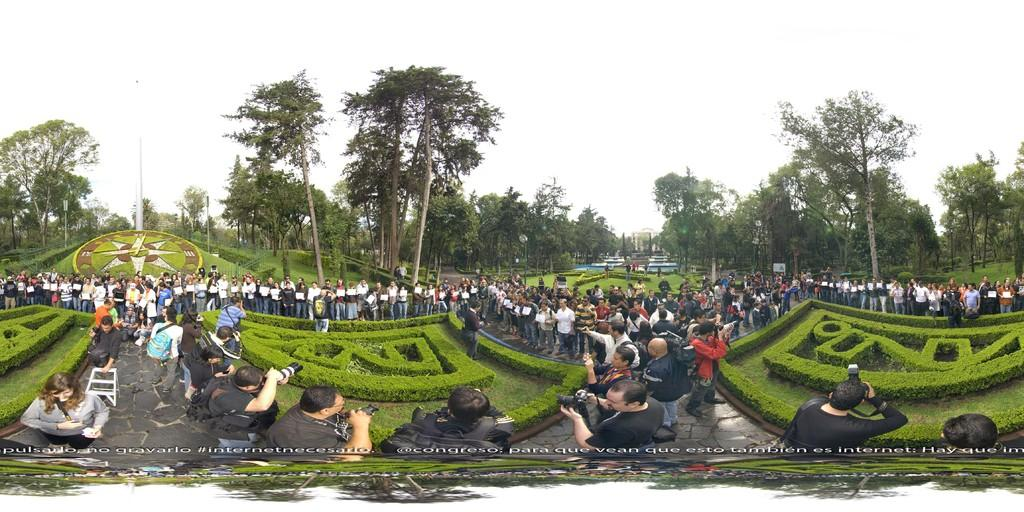What are the people at the bottom of the image doing? The people are standing at the bottom of the image, and they are holding cameras and bags. What can be seen behind the people in the image? There is grass and trees visible behind the people in the image. What is visible at the top of the image? The sky is visible at the top of the image. Reasoning: Let' Let's think step by step in order to produce the conversation. We start by identifying the main subjects in the image, which are the people standing at the bottom. Then, we describe what they are doing, which is holding cameras and bags. Next, we expand the conversation to include the background elements, such as the grass, trees, and sky. Each question is designed to elicit a specific detail about the image that is known from the provided facts. Absurd Question/Answer: What type of crib is visible in the image? There is no crib present in the image. What act are the people performing in the image? The image does not depict a specific act; it simply shows people standing with cameras and bags. What is the main subject of the image? The main subject of the image is a car. Can you describe the car in the image? The car is red and has four wheels. What can be seen in the background of the image? There is a road in the image. What type of road is visible in the image? The road is paved. Reasoning: Let's think step by step in order to produce the conversation. We start by identifying the main subject of the image, which is the car. Then, we describe the car's color and the number of wheels it has. Next, we expand the conversation to include the background elements, such as the road. Finally, we describe the road's condition, which is paved. Each question is designed to elicit a specific detail about the image that is known from the provided facts. Absurd Question/Answer: What type of parrot is sitting on the car's roof in the image? There is no parrot 